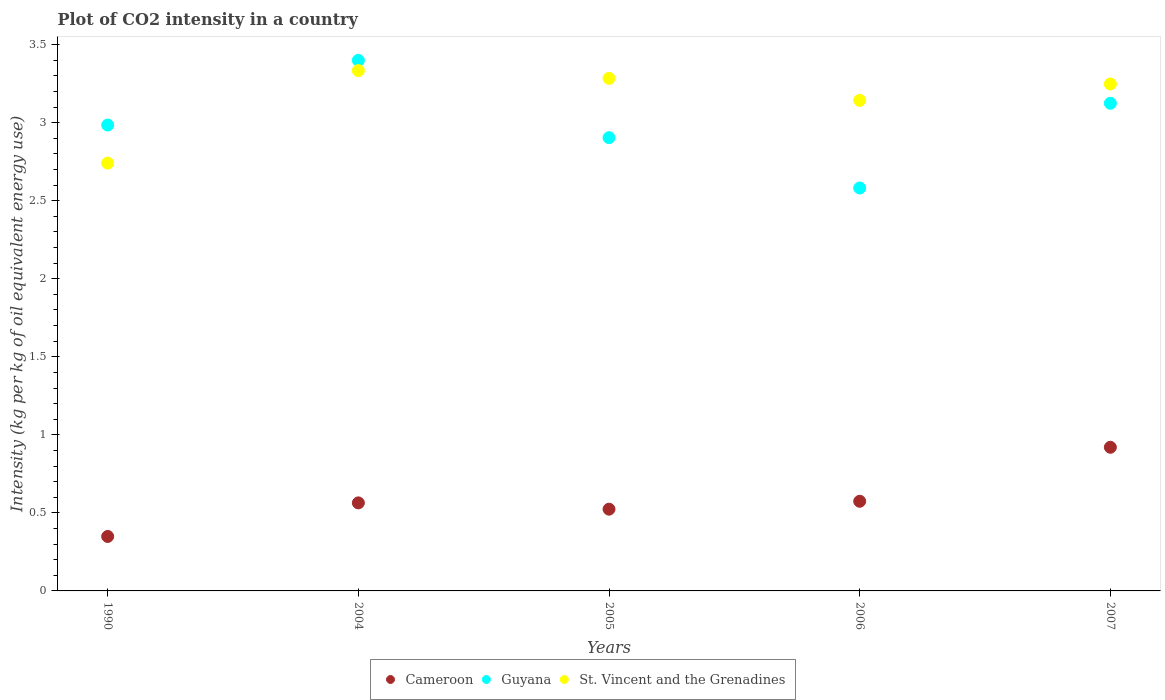How many different coloured dotlines are there?
Give a very brief answer. 3. Is the number of dotlines equal to the number of legend labels?
Offer a very short reply. Yes. What is the CO2 intensity in in Guyana in 2005?
Make the answer very short. 2.9. Across all years, what is the maximum CO2 intensity in in St. Vincent and the Grenadines?
Give a very brief answer. 3.33. Across all years, what is the minimum CO2 intensity in in Guyana?
Offer a very short reply. 2.58. In which year was the CO2 intensity in in Cameroon maximum?
Offer a very short reply. 2007. What is the total CO2 intensity in in Guyana in the graph?
Your answer should be compact. 14.99. What is the difference between the CO2 intensity in in Cameroon in 2004 and that in 2006?
Your answer should be very brief. -0.01. What is the difference between the CO2 intensity in in Cameroon in 2006 and the CO2 intensity in in Guyana in 1990?
Give a very brief answer. -2.41. What is the average CO2 intensity in in St. Vincent and the Grenadines per year?
Offer a terse response. 3.15. In the year 2005, what is the difference between the CO2 intensity in in Guyana and CO2 intensity in in St. Vincent and the Grenadines?
Offer a terse response. -0.38. In how many years, is the CO2 intensity in in Guyana greater than 2.1 kg?
Provide a short and direct response. 5. What is the ratio of the CO2 intensity in in St. Vincent and the Grenadines in 2005 to that in 2007?
Make the answer very short. 1.01. Is the CO2 intensity in in Guyana in 2004 less than that in 2007?
Your answer should be compact. No. Is the difference between the CO2 intensity in in Guyana in 2005 and 2006 greater than the difference between the CO2 intensity in in St. Vincent and the Grenadines in 2005 and 2006?
Give a very brief answer. Yes. What is the difference between the highest and the second highest CO2 intensity in in Cameroon?
Offer a very short reply. 0.35. What is the difference between the highest and the lowest CO2 intensity in in St. Vincent and the Grenadines?
Make the answer very short. 0.59. Is it the case that in every year, the sum of the CO2 intensity in in St. Vincent and the Grenadines and CO2 intensity in in Cameroon  is greater than the CO2 intensity in in Guyana?
Give a very brief answer. Yes. Does the CO2 intensity in in Cameroon monotonically increase over the years?
Provide a short and direct response. No. Is the CO2 intensity in in Cameroon strictly greater than the CO2 intensity in in Guyana over the years?
Your response must be concise. No. Is the CO2 intensity in in Cameroon strictly less than the CO2 intensity in in St. Vincent and the Grenadines over the years?
Keep it short and to the point. Yes. Are the values on the major ticks of Y-axis written in scientific E-notation?
Offer a terse response. No. Does the graph contain grids?
Provide a succinct answer. No. What is the title of the graph?
Offer a terse response. Plot of CO2 intensity in a country. Does "Switzerland" appear as one of the legend labels in the graph?
Make the answer very short. No. What is the label or title of the Y-axis?
Ensure brevity in your answer.  Intensity (kg per kg of oil equivalent energy use). What is the Intensity (kg per kg of oil equivalent energy use) in Cameroon in 1990?
Offer a terse response. 0.35. What is the Intensity (kg per kg of oil equivalent energy use) of Guyana in 1990?
Your answer should be compact. 2.98. What is the Intensity (kg per kg of oil equivalent energy use) of St. Vincent and the Grenadines in 1990?
Your response must be concise. 2.74. What is the Intensity (kg per kg of oil equivalent energy use) of Cameroon in 2004?
Offer a terse response. 0.56. What is the Intensity (kg per kg of oil equivalent energy use) of Guyana in 2004?
Offer a very short reply. 3.4. What is the Intensity (kg per kg of oil equivalent energy use) of St. Vincent and the Grenadines in 2004?
Give a very brief answer. 3.33. What is the Intensity (kg per kg of oil equivalent energy use) in Cameroon in 2005?
Your response must be concise. 0.52. What is the Intensity (kg per kg of oil equivalent energy use) in Guyana in 2005?
Make the answer very short. 2.9. What is the Intensity (kg per kg of oil equivalent energy use) in St. Vincent and the Grenadines in 2005?
Provide a succinct answer. 3.28. What is the Intensity (kg per kg of oil equivalent energy use) of Cameroon in 2006?
Your answer should be very brief. 0.57. What is the Intensity (kg per kg of oil equivalent energy use) in Guyana in 2006?
Keep it short and to the point. 2.58. What is the Intensity (kg per kg of oil equivalent energy use) of St. Vincent and the Grenadines in 2006?
Keep it short and to the point. 3.14. What is the Intensity (kg per kg of oil equivalent energy use) of Cameroon in 2007?
Offer a terse response. 0.92. What is the Intensity (kg per kg of oil equivalent energy use) in Guyana in 2007?
Ensure brevity in your answer.  3.12. What is the Intensity (kg per kg of oil equivalent energy use) of St. Vincent and the Grenadines in 2007?
Provide a short and direct response. 3.25. Across all years, what is the maximum Intensity (kg per kg of oil equivalent energy use) in Cameroon?
Offer a very short reply. 0.92. Across all years, what is the maximum Intensity (kg per kg of oil equivalent energy use) in Guyana?
Make the answer very short. 3.4. Across all years, what is the maximum Intensity (kg per kg of oil equivalent energy use) of St. Vincent and the Grenadines?
Ensure brevity in your answer.  3.33. Across all years, what is the minimum Intensity (kg per kg of oil equivalent energy use) in Cameroon?
Provide a short and direct response. 0.35. Across all years, what is the minimum Intensity (kg per kg of oil equivalent energy use) in Guyana?
Ensure brevity in your answer.  2.58. Across all years, what is the minimum Intensity (kg per kg of oil equivalent energy use) in St. Vincent and the Grenadines?
Ensure brevity in your answer.  2.74. What is the total Intensity (kg per kg of oil equivalent energy use) in Cameroon in the graph?
Your answer should be compact. 2.93. What is the total Intensity (kg per kg of oil equivalent energy use) in Guyana in the graph?
Offer a very short reply. 14.99. What is the total Intensity (kg per kg of oil equivalent energy use) of St. Vincent and the Grenadines in the graph?
Ensure brevity in your answer.  15.75. What is the difference between the Intensity (kg per kg of oil equivalent energy use) in Cameroon in 1990 and that in 2004?
Provide a succinct answer. -0.22. What is the difference between the Intensity (kg per kg of oil equivalent energy use) of Guyana in 1990 and that in 2004?
Your answer should be very brief. -0.41. What is the difference between the Intensity (kg per kg of oil equivalent energy use) in St. Vincent and the Grenadines in 1990 and that in 2004?
Provide a succinct answer. -0.59. What is the difference between the Intensity (kg per kg of oil equivalent energy use) in Cameroon in 1990 and that in 2005?
Offer a very short reply. -0.17. What is the difference between the Intensity (kg per kg of oil equivalent energy use) of Guyana in 1990 and that in 2005?
Your answer should be compact. 0.08. What is the difference between the Intensity (kg per kg of oil equivalent energy use) in St. Vincent and the Grenadines in 1990 and that in 2005?
Your answer should be very brief. -0.54. What is the difference between the Intensity (kg per kg of oil equivalent energy use) in Cameroon in 1990 and that in 2006?
Your response must be concise. -0.23. What is the difference between the Intensity (kg per kg of oil equivalent energy use) in Guyana in 1990 and that in 2006?
Ensure brevity in your answer.  0.4. What is the difference between the Intensity (kg per kg of oil equivalent energy use) of St. Vincent and the Grenadines in 1990 and that in 2006?
Your answer should be compact. -0.4. What is the difference between the Intensity (kg per kg of oil equivalent energy use) in Cameroon in 1990 and that in 2007?
Give a very brief answer. -0.57. What is the difference between the Intensity (kg per kg of oil equivalent energy use) in Guyana in 1990 and that in 2007?
Offer a very short reply. -0.14. What is the difference between the Intensity (kg per kg of oil equivalent energy use) of St. Vincent and the Grenadines in 1990 and that in 2007?
Offer a terse response. -0.51. What is the difference between the Intensity (kg per kg of oil equivalent energy use) of Cameroon in 2004 and that in 2005?
Offer a very short reply. 0.04. What is the difference between the Intensity (kg per kg of oil equivalent energy use) in Guyana in 2004 and that in 2005?
Ensure brevity in your answer.  0.5. What is the difference between the Intensity (kg per kg of oil equivalent energy use) in St. Vincent and the Grenadines in 2004 and that in 2005?
Make the answer very short. 0.05. What is the difference between the Intensity (kg per kg of oil equivalent energy use) of Cameroon in 2004 and that in 2006?
Offer a very short reply. -0.01. What is the difference between the Intensity (kg per kg of oil equivalent energy use) of Guyana in 2004 and that in 2006?
Offer a terse response. 0.82. What is the difference between the Intensity (kg per kg of oil equivalent energy use) in St. Vincent and the Grenadines in 2004 and that in 2006?
Keep it short and to the point. 0.19. What is the difference between the Intensity (kg per kg of oil equivalent energy use) in Cameroon in 2004 and that in 2007?
Provide a short and direct response. -0.36. What is the difference between the Intensity (kg per kg of oil equivalent energy use) in Guyana in 2004 and that in 2007?
Give a very brief answer. 0.27. What is the difference between the Intensity (kg per kg of oil equivalent energy use) in St. Vincent and the Grenadines in 2004 and that in 2007?
Offer a terse response. 0.09. What is the difference between the Intensity (kg per kg of oil equivalent energy use) of Cameroon in 2005 and that in 2006?
Provide a short and direct response. -0.05. What is the difference between the Intensity (kg per kg of oil equivalent energy use) in Guyana in 2005 and that in 2006?
Provide a short and direct response. 0.32. What is the difference between the Intensity (kg per kg of oil equivalent energy use) in St. Vincent and the Grenadines in 2005 and that in 2006?
Provide a short and direct response. 0.14. What is the difference between the Intensity (kg per kg of oil equivalent energy use) of Cameroon in 2005 and that in 2007?
Give a very brief answer. -0.4. What is the difference between the Intensity (kg per kg of oil equivalent energy use) of Guyana in 2005 and that in 2007?
Give a very brief answer. -0.22. What is the difference between the Intensity (kg per kg of oil equivalent energy use) in St. Vincent and the Grenadines in 2005 and that in 2007?
Keep it short and to the point. 0.04. What is the difference between the Intensity (kg per kg of oil equivalent energy use) in Cameroon in 2006 and that in 2007?
Provide a succinct answer. -0.35. What is the difference between the Intensity (kg per kg of oil equivalent energy use) of Guyana in 2006 and that in 2007?
Make the answer very short. -0.54. What is the difference between the Intensity (kg per kg of oil equivalent energy use) in St. Vincent and the Grenadines in 2006 and that in 2007?
Make the answer very short. -0.1. What is the difference between the Intensity (kg per kg of oil equivalent energy use) of Cameroon in 1990 and the Intensity (kg per kg of oil equivalent energy use) of Guyana in 2004?
Your response must be concise. -3.05. What is the difference between the Intensity (kg per kg of oil equivalent energy use) of Cameroon in 1990 and the Intensity (kg per kg of oil equivalent energy use) of St. Vincent and the Grenadines in 2004?
Provide a succinct answer. -2.98. What is the difference between the Intensity (kg per kg of oil equivalent energy use) of Guyana in 1990 and the Intensity (kg per kg of oil equivalent energy use) of St. Vincent and the Grenadines in 2004?
Give a very brief answer. -0.35. What is the difference between the Intensity (kg per kg of oil equivalent energy use) in Cameroon in 1990 and the Intensity (kg per kg of oil equivalent energy use) in Guyana in 2005?
Your answer should be compact. -2.56. What is the difference between the Intensity (kg per kg of oil equivalent energy use) of Cameroon in 1990 and the Intensity (kg per kg of oil equivalent energy use) of St. Vincent and the Grenadines in 2005?
Give a very brief answer. -2.93. What is the difference between the Intensity (kg per kg of oil equivalent energy use) of Guyana in 1990 and the Intensity (kg per kg of oil equivalent energy use) of St. Vincent and the Grenadines in 2005?
Provide a succinct answer. -0.3. What is the difference between the Intensity (kg per kg of oil equivalent energy use) of Cameroon in 1990 and the Intensity (kg per kg of oil equivalent energy use) of Guyana in 2006?
Provide a succinct answer. -2.23. What is the difference between the Intensity (kg per kg of oil equivalent energy use) in Cameroon in 1990 and the Intensity (kg per kg of oil equivalent energy use) in St. Vincent and the Grenadines in 2006?
Make the answer very short. -2.79. What is the difference between the Intensity (kg per kg of oil equivalent energy use) in Guyana in 1990 and the Intensity (kg per kg of oil equivalent energy use) in St. Vincent and the Grenadines in 2006?
Your response must be concise. -0.16. What is the difference between the Intensity (kg per kg of oil equivalent energy use) of Cameroon in 1990 and the Intensity (kg per kg of oil equivalent energy use) of Guyana in 2007?
Provide a succinct answer. -2.78. What is the difference between the Intensity (kg per kg of oil equivalent energy use) of Cameroon in 1990 and the Intensity (kg per kg of oil equivalent energy use) of St. Vincent and the Grenadines in 2007?
Give a very brief answer. -2.9. What is the difference between the Intensity (kg per kg of oil equivalent energy use) of Guyana in 1990 and the Intensity (kg per kg of oil equivalent energy use) of St. Vincent and the Grenadines in 2007?
Offer a terse response. -0.26. What is the difference between the Intensity (kg per kg of oil equivalent energy use) in Cameroon in 2004 and the Intensity (kg per kg of oil equivalent energy use) in Guyana in 2005?
Your answer should be very brief. -2.34. What is the difference between the Intensity (kg per kg of oil equivalent energy use) in Cameroon in 2004 and the Intensity (kg per kg of oil equivalent energy use) in St. Vincent and the Grenadines in 2005?
Offer a very short reply. -2.72. What is the difference between the Intensity (kg per kg of oil equivalent energy use) in Guyana in 2004 and the Intensity (kg per kg of oil equivalent energy use) in St. Vincent and the Grenadines in 2005?
Your answer should be compact. 0.12. What is the difference between the Intensity (kg per kg of oil equivalent energy use) of Cameroon in 2004 and the Intensity (kg per kg of oil equivalent energy use) of Guyana in 2006?
Offer a very short reply. -2.02. What is the difference between the Intensity (kg per kg of oil equivalent energy use) of Cameroon in 2004 and the Intensity (kg per kg of oil equivalent energy use) of St. Vincent and the Grenadines in 2006?
Keep it short and to the point. -2.58. What is the difference between the Intensity (kg per kg of oil equivalent energy use) in Guyana in 2004 and the Intensity (kg per kg of oil equivalent energy use) in St. Vincent and the Grenadines in 2006?
Ensure brevity in your answer.  0.26. What is the difference between the Intensity (kg per kg of oil equivalent energy use) in Cameroon in 2004 and the Intensity (kg per kg of oil equivalent energy use) in Guyana in 2007?
Provide a succinct answer. -2.56. What is the difference between the Intensity (kg per kg of oil equivalent energy use) of Cameroon in 2004 and the Intensity (kg per kg of oil equivalent energy use) of St. Vincent and the Grenadines in 2007?
Keep it short and to the point. -2.68. What is the difference between the Intensity (kg per kg of oil equivalent energy use) in Guyana in 2004 and the Intensity (kg per kg of oil equivalent energy use) in St. Vincent and the Grenadines in 2007?
Provide a succinct answer. 0.15. What is the difference between the Intensity (kg per kg of oil equivalent energy use) in Cameroon in 2005 and the Intensity (kg per kg of oil equivalent energy use) in Guyana in 2006?
Offer a terse response. -2.06. What is the difference between the Intensity (kg per kg of oil equivalent energy use) in Cameroon in 2005 and the Intensity (kg per kg of oil equivalent energy use) in St. Vincent and the Grenadines in 2006?
Offer a terse response. -2.62. What is the difference between the Intensity (kg per kg of oil equivalent energy use) of Guyana in 2005 and the Intensity (kg per kg of oil equivalent energy use) of St. Vincent and the Grenadines in 2006?
Your answer should be very brief. -0.24. What is the difference between the Intensity (kg per kg of oil equivalent energy use) in Cameroon in 2005 and the Intensity (kg per kg of oil equivalent energy use) in Guyana in 2007?
Provide a succinct answer. -2.6. What is the difference between the Intensity (kg per kg of oil equivalent energy use) in Cameroon in 2005 and the Intensity (kg per kg of oil equivalent energy use) in St. Vincent and the Grenadines in 2007?
Your response must be concise. -2.72. What is the difference between the Intensity (kg per kg of oil equivalent energy use) in Guyana in 2005 and the Intensity (kg per kg of oil equivalent energy use) in St. Vincent and the Grenadines in 2007?
Ensure brevity in your answer.  -0.34. What is the difference between the Intensity (kg per kg of oil equivalent energy use) in Cameroon in 2006 and the Intensity (kg per kg of oil equivalent energy use) in Guyana in 2007?
Keep it short and to the point. -2.55. What is the difference between the Intensity (kg per kg of oil equivalent energy use) of Cameroon in 2006 and the Intensity (kg per kg of oil equivalent energy use) of St. Vincent and the Grenadines in 2007?
Your response must be concise. -2.67. What is the difference between the Intensity (kg per kg of oil equivalent energy use) of Guyana in 2006 and the Intensity (kg per kg of oil equivalent energy use) of St. Vincent and the Grenadines in 2007?
Make the answer very short. -0.67. What is the average Intensity (kg per kg of oil equivalent energy use) of Cameroon per year?
Your answer should be compact. 0.59. What is the average Intensity (kg per kg of oil equivalent energy use) in Guyana per year?
Your response must be concise. 3. What is the average Intensity (kg per kg of oil equivalent energy use) of St. Vincent and the Grenadines per year?
Provide a short and direct response. 3.15. In the year 1990, what is the difference between the Intensity (kg per kg of oil equivalent energy use) of Cameroon and Intensity (kg per kg of oil equivalent energy use) of Guyana?
Provide a succinct answer. -2.64. In the year 1990, what is the difference between the Intensity (kg per kg of oil equivalent energy use) of Cameroon and Intensity (kg per kg of oil equivalent energy use) of St. Vincent and the Grenadines?
Provide a succinct answer. -2.39. In the year 1990, what is the difference between the Intensity (kg per kg of oil equivalent energy use) of Guyana and Intensity (kg per kg of oil equivalent energy use) of St. Vincent and the Grenadines?
Provide a succinct answer. 0.24. In the year 2004, what is the difference between the Intensity (kg per kg of oil equivalent energy use) in Cameroon and Intensity (kg per kg of oil equivalent energy use) in Guyana?
Your response must be concise. -2.83. In the year 2004, what is the difference between the Intensity (kg per kg of oil equivalent energy use) of Cameroon and Intensity (kg per kg of oil equivalent energy use) of St. Vincent and the Grenadines?
Offer a terse response. -2.77. In the year 2004, what is the difference between the Intensity (kg per kg of oil equivalent energy use) in Guyana and Intensity (kg per kg of oil equivalent energy use) in St. Vincent and the Grenadines?
Keep it short and to the point. 0.07. In the year 2005, what is the difference between the Intensity (kg per kg of oil equivalent energy use) in Cameroon and Intensity (kg per kg of oil equivalent energy use) in Guyana?
Provide a short and direct response. -2.38. In the year 2005, what is the difference between the Intensity (kg per kg of oil equivalent energy use) of Cameroon and Intensity (kg per kg of oil equivalent energy use) of St. Vincent and the Grenadines?
Ensure brevity in your answer.  -2.76. In the year 2005, what is the difference between the Intensity (kg per kg of oil equivalent energy use) of Guyana and Intensity (kg per kg of oil equivalent energy use) of St. Vincent and the Grenadines?
Offer a very short reply. -0.38. In the year 2006, what is the difference between the Intensity (kg per kg of oil equivalent energy use) of Cameroon and Intensity (kg per kg of oil equivalent energy use) of Guyana?
Your answer should be compact. -2.01. In the year 2006, what is the difference between the Intensity (kg per kg of oil equivalent energy use) in Cameroon and Intensity (kg per kg of oil equivalent energy use) in St. Vincent and the Grenadines?
Give a very brief answer. -2.57. In the year 2006, what is the difference between the Intensity (kg per kg of oil equivalent energy use) of Guyana and Intensity (kg per kg of oil equivalent energy use) of St. Vincent and the Grenadines?
Offer a very short reply. -0.56. In the year 2007, what is the difference between the Intensity (kg per kg of oil equivalent energy use) of Cameroon and Intensity (kg per kg of oil equivalent energy use) of Guyana?
Provide a succinct answer. -2.2. In the year 2007, what is the difference between the Intensity (kg per kg of oil equivalent energy use) in Cameroon and Intensity (kg per kg of oil equivalent energy use) in St. Vincent and the Grenadines?
Offer a terse response. -2.33. In the year 2007, what is the difference between the Intensity (kg per kg of oil equivalent energy use) in Guyana and Intensity (kg per kg of oil equivalent energy use) in St. Vincent and the Grenadines?
Make the answer very short. -0.12. What is the ratio of the Intensity (kg per kg of oil equivalent energy use) in Cameroon in 1990 to that in 2004?
Provide a short and direct response. 0.62. What is the ratio of the Intensity (kg per kg of oil equivalent energy use) in Guyana in 1990 to that in 2004?
Provide a short and direct response. 0.88. What is the ratio of the Intensity (kg per kg of oil equivalent energy use) in St. Vincent and the Grenadines in 1990 to that in 2004?
Your answer should be compact. 0.82. What is the ratio of the Intensity (kg per kg of oil equivalent energy use) in Cameroon in 1990 to that in 2005?
Your response must be concise. 0.67. What is the ratio of the Intensity (kg per kg of oil equivalent energy use) in Guyana in 1990 to that in 2005?
Your answer should be compact. 1.03. What is the ratio of the Intensity (kg per kg of oil equivalent energy use) in St. Vincent and the Grenadines in 1990 to that in 2005?
Offer a very short reply. 0.83. What is the ratio of the Intensity (kg per kg of oil equivalent energy use) in Cameroon in 1990 to that in 2006?
Your answer should be compact. 0.61. What is the ratio of the Intensity (kg per kg of oil equivalent energy use) of Guyana in 1990 to that in 2006?
Provide a short and direct response. 1.16. What is the ratio of the Intensity (kg per kg of oil equivalent energy use) in St. Vincent and the Grenadines in 1990 to that in 2006?
Give a very brief answer. 0.87. What is the ratio of the Intensity (kg per kg of oil equivalent energy use) of Cameroon in 1990 to that in 2007?
Offer a very short reply. 0.38. What is the ratio of the Intensity (kg per kg of oil equivalent energy use) in Guyana in 1990 to that in 2007?
Offer a terse response. 0.96. What is the ratio of the Intensity (kg per kg of oil equivalent energy use) in St. Vincent and the Grenadines in 1990 to that in 2007?
Provide a succinct answer. 0.84. What is the ratio of the Intensity (kg per kg of oil equivalent energy use) of Cameroon in 2004 to that in 2005?
Your answer should be compact. 1.08. What is the ratio of the Intensity (kg per kg of oil equivalent energy use) of Guyana in 2004 to that in 2005?
Offer a terse response. 1.17. What is the ratio of the Intensity (kg per kg of oil equivalent energy use) in St. Vincent and the Grenadines in 2004 to that in 2005?
Provide a short and direct response. 1.02. What is the ratio of the Intensity (kg per kg of oil equivalent energy use) in Cameroon in 2004 to that in 2006?
Your response must be concise. 0.98. What is the ratio of the Intensity (kg per kg of oil equivalent energy use) in Guyana in 2004 to that in 2006?
Give a very brief answer. 1.32. What is the ratio of the Intensity (kg per kg of oil equivalent energy use) of St. Vincent and the Grenadines in 2004 to that in 2006?
Your answer should be compact. 1.06. What is the ratio of the Intensity (kg per kg of oil equivalent energy use) of Cameroon in 2004 to that in 2007?
Ensure brevity in your answer.  0.61. What is the ratio of the Intensity (kg per kg of oil equivalent energy use) of Guyana in 2004 to that in 2007?
Keep it short and to the point. 1.09. What is the ratio of the Intensity (kg per kg of oil equivalent energy use) of St. Vincent and the Grenadines in 2004 to that in 2007?
Ensure brevity in your answer.  1.03. What is the ratio of the Intensity (kg per kg of oil equivalent energy use) in Cameroon in 2005 to that in 2006?
Provide a succinct answer. 0.91. What is the ratio of the Intensity (kg per kg of oil equivalent energy use) in Guyana in 2005 to that in 2006?
Your answer should be very brief. 1.12. What is the ratio of the Intensity (kg per kg of oil equivalent energy use) in St. Vincent and the Grenadines in 2005 to that in 2006?
Your answer should be compact. 1.04. What is the ratio of the Intensity (kg per kg of oil equivalent energy use) of Cameroon in 2005 to that in 2007?
Offer a terse response. 0.57. What is the ratio of the Intensity (kg per kg of oil equivalent energy use) of Guyana in 2005 to that in 2007?
Give a very brief answer. 0.93. What is the ratio of the Intensity (kg per kg of oil equivalent energy use) in St. Vincent and the Grenadines in 2005 to that in 2007?
Your answer should be compact. 1.01. What is the ratio of the Intensity (kg per kg of oil equivalent energy use) of Cameroon in 2006 to that in 2007?
Provide a succinct answer. 0.62. What is the ratio of the Intensity (kg per kg of oil equivalent energy use) of Guyana in 2006 to that in 2007?
Provide a succinct answer. 0.83. What is the ratio of the Intensity (kg per kg of oil equivalent energy use) of St. Vincent and the Grenadines in 2006 to that in 2007?
Keep it short and to the point. 0.97. What is the difference between the highest and the second highest Intensity (kg per kg of oil equivalent energy use) in Cameroon?
Give a very brief answer. 0.35. What is the difference between the highest and the second highest Intensity (kg per kg of oil equivalent energy use) in Guyana?
Your answer should be very brief. 0.27. What is the difference between the highest and the second highest Intensity (kg per kg of oil equivalent energy use) of St. Vincent and the Grenadines?
Ensure brevity in your answer.  0.05. What is the difference between the highest and the lowest Intensity (kg per kg of oil equivalent energy use) in Cameroon?
Provide a short and direct response. 0.57. What is the difference between the highest and the lowest Intensity (kg per kg of oil equivalent energy use) in Guyana?
Your answer should be very brief. 0.82. What is the difference between the highest and the lowest Intensity (kg per kg of oil equivalent energy use) of St. Vincent and the Grenadines?
Provide a succinct answer. 0.59. 